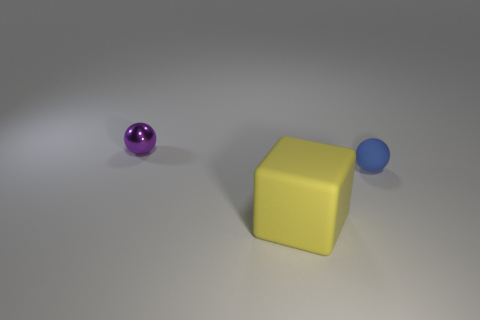Are there an equal number of small metallic balls left of the large matte cube and large yellow cubes that are in front of the small purple metallic object?
Ensure brevity in your answer.  Yes. Are there more blue matte things that are left of the yellow block than big yellow matte blocks?
Offer a terse response. No. What is the material of the small purple object?
Offer a terse response. Metal. What shape is the tiny blue thing that is made of the same material as the yellow cube?
Offer a terse response. Sphere. There is a yellow block in front of the ball that is to the left of the tiny blue ball; what size is it?
Your answer should be very brief. Large. There is a sphere that is on the right side of the large cube; what color is it?
Give a very brief answer. Blue. Is there a tiny blue rubber object that has the same shape as the small purple thing?
Your answer should be very brief. Yes. Are there fewer large yellow objects to the right of the small rubber thing than tiny things that are to the left of the big rubber object?
Provide a short and direct response. Yes. What color is the metal object?
Offer a very short reply. Purple. Is there a tiny rubber ball in front of the tiny ball that is in front of the small purple metallic sphere?
Make the answer very short. No. 